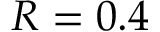<formula> <loc_0><loc_0><loc_500><loc_500>R = 0 . 4</formula> 